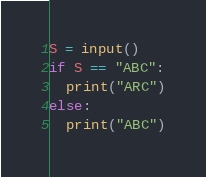<code> <loc_0><loc_0><loc_500><loc_500><_Python_>S = input()
if S == "ABC":
  print("ARC")
else:
  print("ABC")</code> 